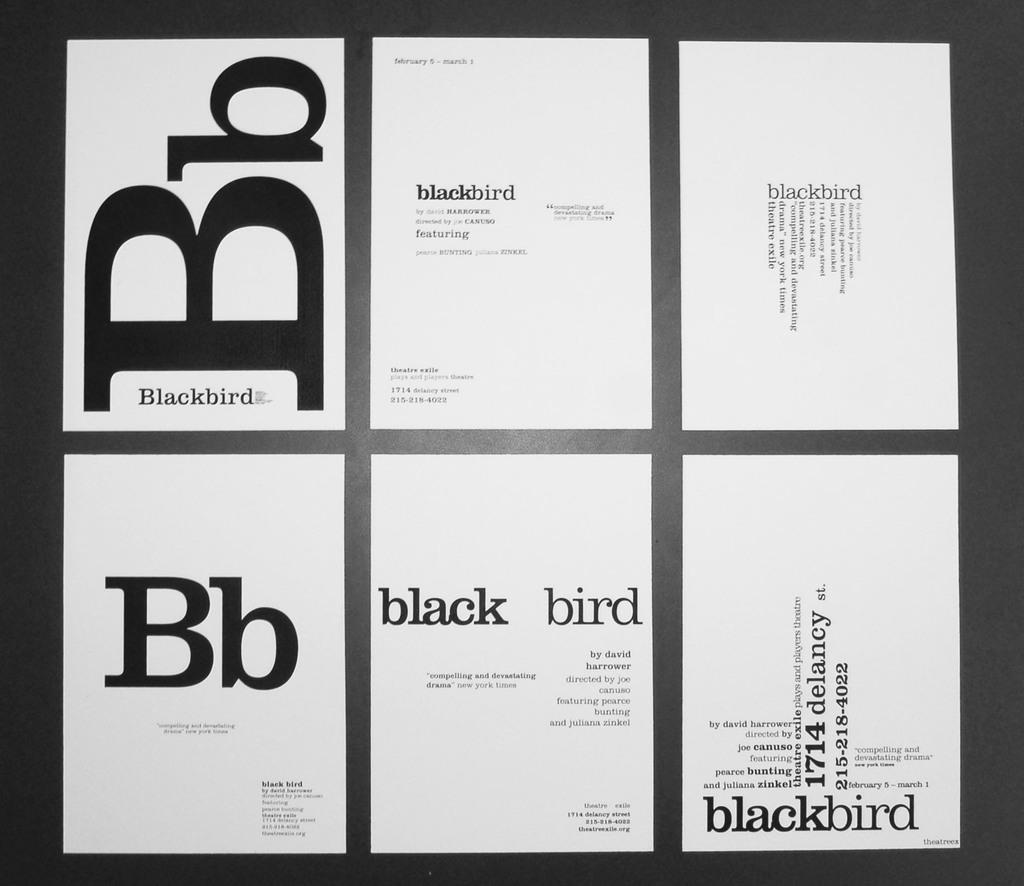<image>
Offer a succinct explanation of the picture presented. A grouping of several pieces of paper that have several words written on them including the word blackbird. 